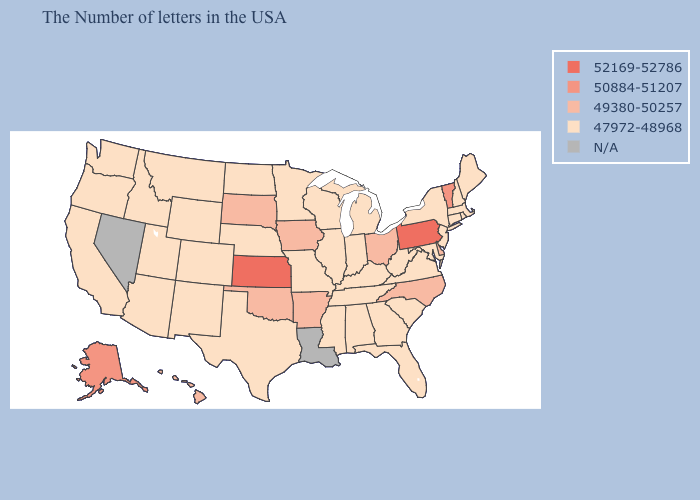Name the states that have a value in the range N/A?
Concise answer only. Louisiana, Nevada. Does Virginia have the highest value in the South?
Short answer required. No. Name the states that have a value in the range 47972-48968?
Short answer required. Maine, Massachusetts, Rhode Island, New Hampshire, Connecticut, New York, New Jersey, Maryland, Virginia, South Carolina, West Virginia, Florida, Georgia, Michigan, Kentucky, Indiana, Alabama, Tennessee, Wisconsin, Illinois, Mississippi, Missouri, Minnesota, Nebraska, Texas, North Dakota, Wyoming, Colorado, New Mexico, Utah, Montana, Arizona, Idaho, California, Washington, Oregon. Among the states that border West Virginia , which have the highest value?
Keep it brief. Pennsylvania. What is the value of Minnesota?
Keep it brief. 47972-48968. What is the highest value in the West ?
Give a very brief answer. 50884-51207. Name the states that have a value in the range 49380-50257?
Answer briefly. Delaware, North Carolina, Ohio, Arkansas, Iowa, Oklahoma, South Dakota, Hawaii. Does Arkansas have the lowest value in the USA?
Answer briefly. No. Does the map have missing data?
Keep it brief. Yes. What is the value of Alabama?
Write a very short answer. 47972-48968. What is the value of Delaware?
Write a very short answer. 49380-50257. Does Wyoming have the lowest value in the West?
Give a very brief answer. Yes. Name the states that have a value in the range 52169-52786?
Answer briefly. Pennsylvania, Kansas. What is the highest value in states that border New Hampshire?
Concise answer only. 50884-51207. 